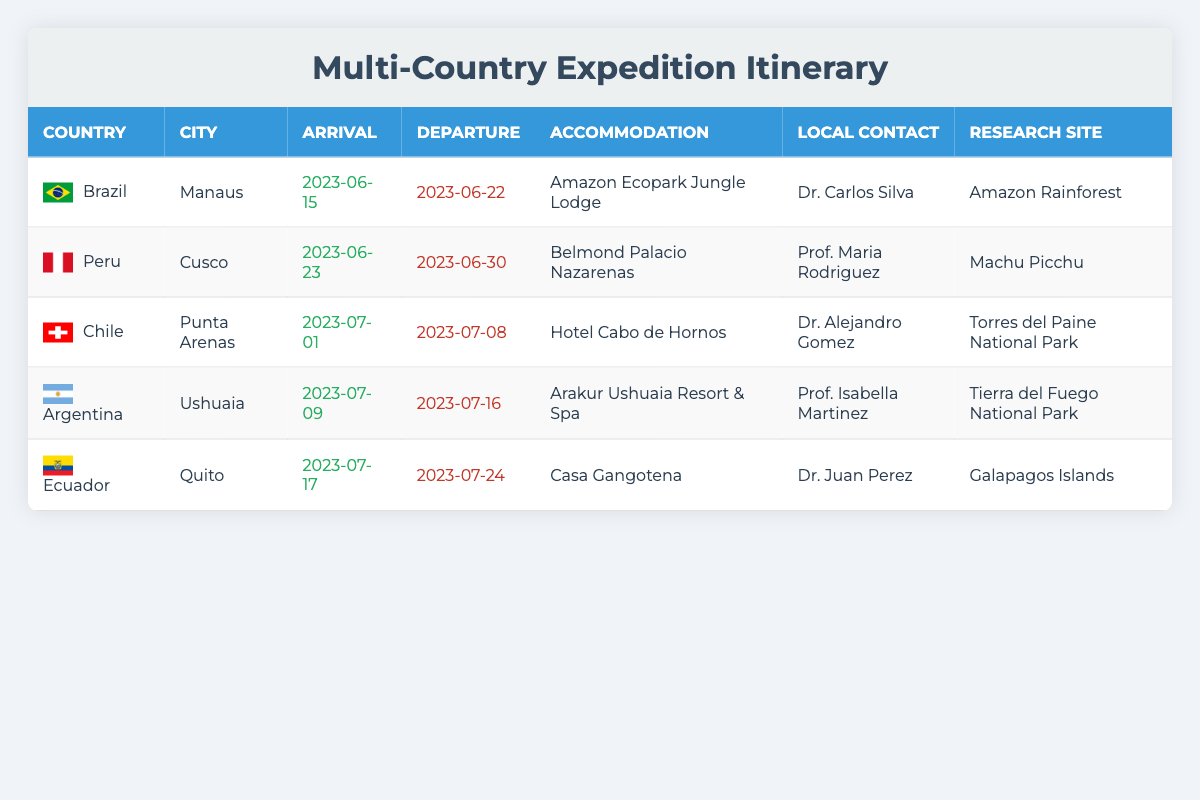What is the accommodation in Brazil? The table lists "Amazon Ecopark Jungle Lodge" as the accommodation for the expedition in Brazil.
Answer: Amazon Ecopark Jungle Lodge Who is the local contact in Peru? The local contact in Peru is "Prof. Maria Rodriguez" according to the table.
Answer: Prof. Maria Rodriguez Which city is the last stop on the expedition? From the itinerary, the last city listed for the expedition is "Quito" in Ecuador, marking the final stop.
Answer: Quito What are the arrival and departure dates for the trip to Chile? The arrival date in Chile is "2023-07-01" and the departure date is "2023-07-08" as specified in the table.
Answer: Arrival: 2023-07-01, Departure: 2023-07-08 Is there a local contact for the research in Argentina? Yes, the table indicates that "Prof. Isabella Martinez" is the local contact for the research in Argentina.
Answer: Yes What is the total number of countries covered in the expedition? The table reveals that there are five countries listed: Brazil, Peru, Chile, Argentina, and Ecuador, leading to a total of five countries.
Answer: 5 How many days are spent in each country? In Brazil: 7 days (22-15), Peru: 7 days (30-23), Chile: 7 days (8-1), Argentina: 7 days (16-9), Ecuador: 7 days (24-17); they all span 7 days each.
Answer: 7 days each Which research site is visited in Ecuador? The table shows that the research site in Ecuador is "Galapagos Islands."
Answer: Galapagos Islands What is the time gap between the arrival in Brazil and departure from Peru? The arrival in Brazil is on "2023-06-15" and the departure from Peru is on "2023-06-30," giving a gap of 15 days.
Answer: 15 days Can you list the cities where the research will take place chronologically? The cities for research are Manaus (Brazil), Cusco (Peru), Punta Arenas (Chile), Ushuaia (Argentina), and Quito (Ecuador), in that order.
Answer: Manaus, Cusco, Punta Arenas, Ushuaia, Quito 